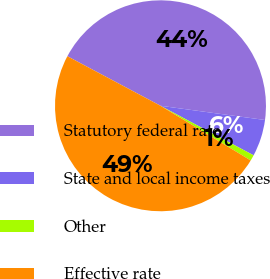<chart> <loc_0><loc_0><loc_500><loc_500><pie_chart><fcel>Statutory federal rate<fcel>State and local income taxes<fcel>Other<fcel>Effective rate<nl><fcel>44.37%<fcel>5.63%<fcel>0.89%<fcel>49.11%<nl></chart> 